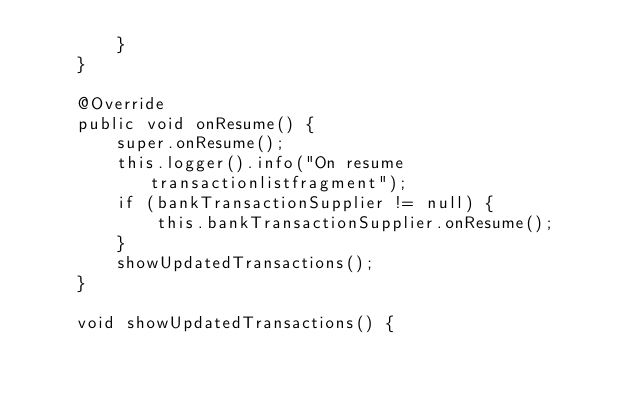Convert code to text. <code><loc_0><loc_0><loc_500><loc_500><_Java_>        }
    }

    @Override
    public void onResume() {
        super.onResume();
        this.logger().info("On resume transactionlistfragment");
        if (bankTransactionSupplier != null) {
            this.bankTransactionSupplier.onResume();
        }
        showUpdatedTransactions();
    }

    void showUpdatedTransactions() {</code> 